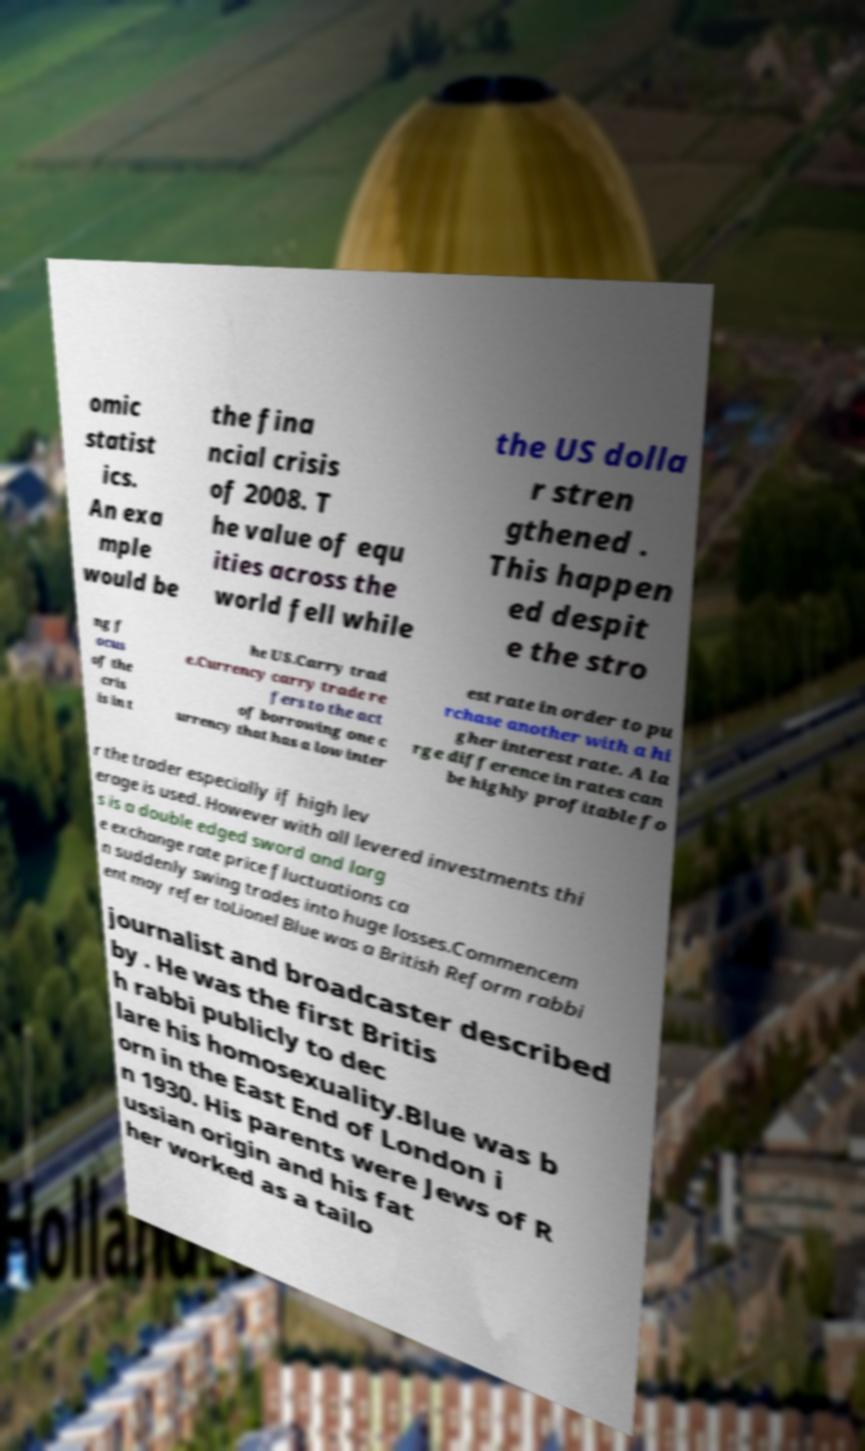Please identify and transcribe the text found in this image. omic statist ics. An exa mple would be the fina ncial crisis of 2008. T he value of equ ities across the world fell while the US dolla r stren gthened . This happen ed despit e the stro ng f ocus of the cris is in t he US.Carry trad e.Currency carry trade re fers to the act of borrowing one c urrency that has a low inter est rate in order to pu rchase another with a hi gher interest rate. A la rge difference in rates can be highly profitable fo r the trader especially if high lev erage is used. However with all levered investments thi s is a double edged sword and larg e exchange rate price fluctuations ca n suddenly swing trades into huge losses.Commencem ent may refer toLionel Blue was a British Reform rabbi journalist and broadcaster described by . He was the first Britis h rabbi publicly to dec lare his homosexuality.Blue was b orn in the East End of London i n 1930. His parents were Jews of R ussian origin and his fat her worked as a tailo 